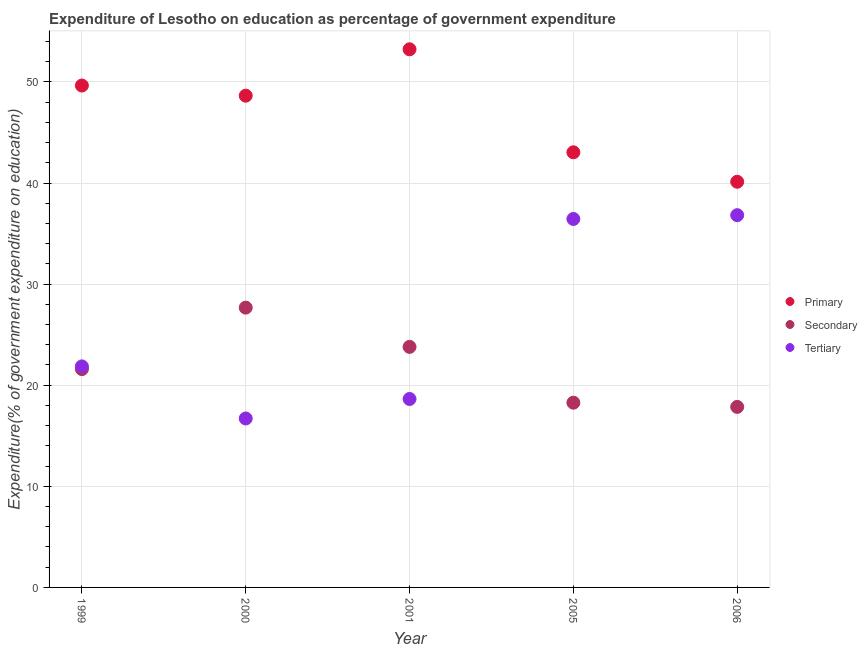How many different coloured dotlines are there?
Ensure brevity in your answer.  3. What is the expenditure on tertiary education in 2001?
Your response must be concise. 18.64. Across all years, what is the maximum expenditure on tertiary education?
Offer a very short reply. 36.82. Across all years, what is the minimum expenditure on secondary education?
Give a very brief answer. 17.86. In which year was the expenditure on primary education maximum?
Provide a short and direct response. 2001. What is the total expenditure on tertiary education in the graph?
Provide a short and direct response. 130.47. What is the difference between the expenditure on tertiary education in 2005 and that in 2006?
Keep it short and to the point. -0.37. What is the difference between the expenditure on tertiary education in 2000 and the expenditure on secondary education in 2005?
Provide a short and direct response. -1.56. What is the average expenditure on tertiary education per year?
Offer a very short reply. 26.09. In the year 2006, what is the difference between the expenditure on primary education and expenditure on secondary education?
Give a very brief answer. 22.27. What is the ratio of the expenditure on tertiary education in 2000 to that in 2001?
Give a very brief answer. 0.9. What is the difference between the highest and the second highest expenditure on secondary education?
Ensure brevity in your answer.  3.88. What is the difference between the highest and the lowest expenditure on tertiary education?
Offer a very short reply. 20.11. Does the expenditure on secondary education monotonically increase over the years?
Provide a succinct answer. No. Is the expenditure on tertiary education strictly less than the expenditure on secondary education over the years?
Your answer should be compact. No. How many years are there in the graph?
Your response must be concise. 5. What is the difference between two consecutive major ticks on the Y-axis?
Your response must be concise. 10. Does the graph contain any zero values?
Provide a short and direct response. No. Where does the legend appear in the graph?
Give a very brief answer. Center right. How are the legend labels stacked?
Give a very brief answer. Vertical. What is the title of the graph?
Provide a succinct answer. Expenditure of Lesotho on education as percentage of government expenditure. What is the label or title of the X-axis?
Offer a very short reply. Year. What is the label or title of the Y-axis?
Provide a short and direct response. Expenditure(% of government expenditure on education). What is the Expenditure(% of government expenditure on education) in Primary in 1999?
Provide a succinct answer. 49.64. What is the Expenditure(% of government expenditure on education) in Secondary in 1999?
Offer a terse response. 21.59. What is the Expenditure(% of government expenditure on education) in Tertiary in 1999?
Make the answer very short. 21.86. What is the Expenditure(% of government expenditure on education) in Primary in 2000?
Offer a terse response. 48.64. What is the Expenditure(% of government expenditure on education) in Secondary in 2000?
Make the answer very short. 27.67. What is the Expenditure(% of government expenditure on education) in Tertiary in 2000?
Provide a short and direct response. 16.71. What is the Expenditure(% of government expenditure on education) in Primary in 2001?
Offer a very short reply. 53.23. What is the Expenditure(% of government expenditure on education) in Secondary in 2001?
Your answer should be very brief. 23.79. What is the Expenditure(% of government expenditure on education) of Tertiary in 2001?
Your response must be concise. 18.64. What is the Expenditure(% of government expenditure on education) in Primary in 2005?
Your response must be concise. 43.04. What is the Expenditure(% of government expenditure on education) of Secondary in 2005?
Offer a very short reply. 18.27. What is the Expenditure(% of government expenditure on education) of Tertiary in 2005?
Make the answer very short. 36.44. What is the Expenditure(% of government expenditure on education) of Primary in 2006?
Provide a succinct answer. 40.12. What is the Expenditure(% of government expenditure on education) of Secondary in 2006?
Ensure brevity in your answer.  17.86. What is the Expenditure(% of government expenditure on education) of Tertiary in 2006?
Offer a terse response. 36.82. Across all years, what is the maximum Expenditure(% of government expenditure on education) of Primary?
Offer a terse response. 53.23. Across all years, what is the maximum Expenditure(% of government expenditure on education) in Secondary?
Keep it short and to the point. 27.67. Across all years, what is the maximum Expenditure(% of government expenditure on education) in Tertiary?
Your answer should be very brief. 36.82. Across all years, what is the minimum Expenditure(% of government expenditure on education) in Primary?
Make the answer very short. 40.12. Across all years, what is the minimum Expenditure(% of government expenditure on education) in Secondary?
Make the answer very short. 17.86. Across all years, what is the minimum Expenditure(% of government expenditure on education) in Tertiary?
Your answer should be compact. 16.71. What is the total Expenditure(% of government expenditure on education) in Primary in the graph?
Keep it short and to the point. 234.67. What is the total Expenditure(% of government expenditure on education) of Secondary in the graph?
Your answer should be compact. 109.19. What is the total Expenditure(% of government expenditure on education) in Tertiary in the graph?
Keep it short and to the point. 130.47. What is the difference between the Expenditure(% of government expenditure on education) of Secondary in 1999 and that in 2000?
Make the answer very short. -6.08. What is the difference between the Expenditure(% of government expenditure on education) in Tertiary in 1999 and that in 2000?
Offer a very short reply. 5.15. What is the difference between the Expenditure(% of government expenditure on education) of Primary in 1999 and that in 2001?
Offer a very short reply. -3.58. What is the difference between the Expenditure(% of government expenditure on education) in Secondary in 1999 and that in 2001?
Keep it short and to the point. -2.2. What is the difference between the Expenditure(% of government expenditure on education) in Tertiary in 1999 and that in 2001?
Your response must be concise. 3.22. What is the difference between the Expenditure(% of government expenditure on education) of Primary in 1999 and that in 2005?
Your response must be concise. 6.61. What is the difference between the Expenditure(% of government expenditure on education) of Secondary in 1999 and that in 2005?
Give a very brief answer. 3.32. What is the difference between the Expenditure(% of government expenditure on education) in Tertiary in 1999 and that in 2005?
Offer a terse response. -14.58. What is the difference between the Expenditure(% of government expenditure on education) of Primary in 1999 and that in 2006?
Provide a succinct answer. 9.52. What is the difference between the Expenditure(% of government expenditure on education) of Secondary in 1999 and that in 2006?
Keep it short and to the point. 3.74. What is the difference between the Expenditure(% of government expenditure on education) in Tertiary in 1999 and that in 2006?
Provide a succinct answer. -14.96. What is the difference between the Expenditure(% of government expenditure on education) in Primary in 2000 and that in 2001?
Provide a short and direct response. -4.59. What is the difference between the Expenditure(% of government expenditure on education) in Secondary in 2000 and that in 2001?
Provide a succinct answer. 3.88. What is the difference between the Expenditure(% of government expenditure on education) in Tertiary in 2000 and that in 2001?
Offer a terse response. -1.93. What is the difference between the Expenditure(% of government expenditure on education) of Primary in 2000 and that in 2005?
Your answer should be compact. 5.6. What is the difference between the Expenditure(% of government expenditure on education) of Secondary in 2000 and that in 2005?
Your answer should be very brief. 9.4. What is the difference between the Expenditure(% of government expenditure on education) in Tertiary in 2000 and that in 2005?
Give a very brief answer. -19.73. What is the difference between the Expenditure(% of government expenditure on education) of Primary in 2000 and that in 2006?
Give a very brief answer. 8.51. What is the difference between the Expenditure(% of government expenditure on education) of Secondary in 2000 and that in 2006?
Provide a succinct answer. 9.82. What is the difference between the Expenditure(% of government expenditure on education) in Tertiary in 2000 and that in 2006?
Ensure brevity in your answer.  -20.11. What is the difference between the Expenditure(% of government expenditure on education) of Primary in 2001 and that in 2005?
Your response must be concise. 10.19. What is the difference between the Expenditure(% of government expenditure on education) in Secondary in 2001 and that in 2005?
Keep it short and to the point. 5.52. What is the difference between the Expenditure(% of government expenditure on education) in Tertiary in 2001 and that in 2005?
Offer a very short reply. -17.81. What is the difference between the Expenditure(% of government expenditure on education) in Primary in 2001 and that in 2006?
Keep it short and to the point. 13.1. What is the difference between the Expenditure(% of government expenditure on education) of Secondary in 2001 and that in 2006?
Ensure brevity in your answer.  5.94. What is the difference between the Expenditure(% of government expenditure on education) in Tertiary in 2001 and that in 2006?
Ensure brevity in your answer.  -18.18. What is the difference between the Expenditure(% of government expenditure on education) of Primary in 2005 and that in 2006?
Provide a short and direct response. 2.91. What is the difference between the Expenditure(% of government expenditure on education) in Secondary in 2005 and that in 2006?
Offer a terse response. 0.42. What is the difference between the Expenditure(% of government expenditure on education) of Tertiary in 2005 and that in 2006?
Provide a succinct answer. -0.37. What is the difference between the Expenditure(% of government expenditure on education) in Primary in 1999 and the Expenditure(% of government expenditure on education) in Secondary in 2000?
Give a very brief answer. 21.97. What is the difference between the Expenditure(% of government expenditure on education) of Primary in 1999 and the Expenditure(% of government expenditure on education) of Tertiary in 2000?
Offer a terse response. 32.93. What is the difference between the Expenditure(% of government expenditure on education) of Secondary in 1999 and the Expenditure(% of government expenditure on education) of Tertiary in 2000?
Your response must be concise. 4.88. What is the difference between the Expenditure(% of government expenditure on education) in Primary in 1999 and the Expenditure(% of government expenditure on education) in Secondary in 2001?
Offer a very short reply. 25.85. What is the difference between the Expenditure(% of government expenditure on education) of Primary in 1999 and the Expenditure(% of government expenditure on education) of Tertiary in 2001?
Provide a short and direct response. 31. What is the difference between the Expenditure(% of government expenditure on education) in Secondary in 1999 and the Expenditure(% of government expenditure on education) in Tertiary in 2001?
Your response must be concise. 2.95. What is the difference between the Expenditure(% of government expenditure on education) of Primary in 1999 and the Expenditure(% of government expenditure on education) of Secondary in 2005?
Your response must be concise. 31.37. What is the difference between the Expenditure(% of government expenditure on education) in Primary in 1999 and the Expenditure(% of government expenditure on education) in Tertiary in 2005?
Provide a succinct answer. 13.2. What is the difference between the Expenditure(% of government expenditure on education) of Secondary in 1999 and the Expenditure(% of government expenditure on education) of Tertiary in 2005?
Your answer should be very brief. -14.85. What is the difference between the Expenditure(% of government expenditure on education) of Primary in 1999 and the Expenditure(% of government expenditure on education) of Secondary in 2006?
Keep it short and to the point. 31.79. What is the difference between the Expenditure(% of government expenditure on education) in Primary in 1999 and the Expenditure(% of government expenditure on education) in Tertiary in 2006?
Provide a succinct answer. 12.82. What is the difference between the Expenditure(% of government expenditure on education) of Secondary in 1999 and the Expenditure(% of government expenditure on education) of Tertiary in 2006?
Your answer should be very brief. -15.23. What is the difference between the Expenditure(% of government expenditure on education) in Primary in 2000 and the Expenditure(% of government expenditure on education) in Secondary in 2001?
Offer a very short reply. 24.85. What is the difference between the Expenditure(% of government expenditure on education) of Primary in 2000 and the Expenditure(% of government expenditure on education) of Tertiary in 2001?
Offer a terse response. 30. What is the difference between the Expenditure(% of government expenditure on education) in Secondary in 2000 and the Expenditure(% of government expenditure on education) in Tertiary in 2001?
Provide a succinct answer. 9.04. What is the difference between the Expenditure(% of government expenditure on education) in Primary in 2000 and the Expenditure(% of government expenditure on education) in Secondary in 2005?
Provide a short and direct response. 30.37. What is the difference between the Expenditure(% of government expenditure on education) of Primary in 2000 and the Expenditure(% of government expenditure on education) of Tertiary in 2005?
Make the answer very short. 12.19. What is the difference between the Expenditure(% of government expenditure on education) in Secondary in 2000 and the Expenditure(% of government expenditure on education) in Tertiary in 2005?
Keep it short and to the point. -8.77. What is the difference between the Expenditure(% of government expenditure on education) of Primary in 2000 and the Expenditure(% of government expenditure on education) of Secondary in 2006?
Provide a short and direct response. 30.78. What is the difference between the Expenditure(% of government expenditure on education) in Primary in 2000 and the Expenditure(% of government expenditure on education) in Tertiary in 2006?
Give a very brief answer. 11.82. What is the difference between the Expenditure(% of government expenditure on education) of Secondary in 2000 and the Expenditure(% of government expenditure on education) of Tertiary in 2006?
Give a very brief answer. -9.14. What is the difference between the Expenditure(% of government expenditure on education) of Primary in 2001 and the Expenditure(% of government expenditure on education) of Secondary in 2005?
Your answer should be very brief. 34.95. What is the difference between the Expenditure(% of government expenditure on education) of Primary in 2001 and the Expenditure(% of government expenditure on education) of Tertiary in 2005?
Make the answer very short. 16.78. What is the difference between the Expenditure(% of government expenditure on education) in Secondary in 2001 and the Expenditure(% of government expenditure on education) in Tertiary in 2005?
Make the answer very short. -12.65. What is the difference between the Expenditure(% of government expenditure on education) of Primary in 2001 and the Expenditure(% of government expenditure on education) of Secondary in 2006?
Provide a short and direct response. 35.37. What is the difference between the Expenditure(% of government expenditure on education) in Primary in 2001 and the Expenditure(% of government expenditure on education) in Tertiary in 2006?
Make the answer very short. 16.41. What is the difference between the Expenditure(% of government expenditure on education) of Secondary in 2001 and the Expenditure(% of government expenditure on education) of Tertiary in 2006?
Your answer should be compact. -13.03. What is the difference between the Expenditure(% of government expenditure on education) in Primary in 2005 and the Expenditure(% of government expenditure on education) in Secondary in 2006?
Offer a terse response. 25.18. What is the difference between the Expenditure(% of government expenditure on education) in Primary in 2005 and the Expenditure(% of government expenditure on education) in Tertiary in 2006?
Make the answer very short. 6.22. What is the difference between the Expenditure(% of government expenditure on education) of Secondary in 2005 and the Expenditure(% of government expenditure on education) of Tertiary in 2006?
Provide a succinct answer. -18.55. What is the average Expenditure(% of government expenditure on education) of Primary per year?
Your answer should be compact. 46.93. What is the average Expenditure(% of government expenditure on education) in Secondary per year?
Offer a very short reply. 21.84. What is the average Expenditure(% of government expenditure on education) in Tertiary per year?
Give a very brief answer. 26.09. In the year 1999, what is the difference between the Expenditure(% of government expenditure on education) of Primary and Expenditure(% of government expenditure on education) of Secondary?
Ensure brevity in your answer.  28.05. In the year 1999, what is the difference between the Expenditure(% of government expenditure on education) in Primary and Expenditure(% of government expenditure on education) in Tertiary?
Provide a short and direct response. 27.78. In the year 1999, what is the difference between the Expenditure(% of government expenditure on education) of Secondary and Expenditure(% of government expenditure on education) of Tertiary?
Provide a succinct answer. -0.27. In the year 2000, what is the difference between the Expenditure(% of government expenditure on education) in Primary and Expenditure(% of government expenditure on education) in Secondary?
Provide a succinct answer. 20.96. In the year 2000, what is the difference between the Expenditure(% of government expenditure on education) in Primary and Expenditure(% of government expenditure on education) in Tertiary?
Give a very brief answer. 31.93. In the year 2000, what is the difference between the Expenditure(% of government expenditure on education) in Secondary and Expenditure(% of government expenditure on education) in Tertiary?
Ensure brevity in your answer.  10.96. In the year 2001, what is the difference between the Expenditure(% of government expenditure on education) of Primary and Expenditure(% of government expenditure on education) of Secondary?
Keep it short and to the point. 29.44. In the year 2001, what is the difference between the Expenditure(% of government expenditure on education) in Primary and Expenditure(% of government expenditure on education) in Tertiary?
Give a very brief answer. 34.59. In the year 2001, what is the difference between the Expenditure(% of government expenditure on education) in Secondary and Expenditure(% of government expenditure on education) in Tertiary?
Keep it short and to the point. 5.15. In the year 2005, what is the difference between the Expenditure(% of government expenditure on education) in Primary and Expenditure(% of government expenditure on education) in Secondary?
Your response must be concise. 24.76. In the year 2005, what is the difference between the Expenditure(% of government expenditure on education) in Primary and Expenditure(% of government expenditure on education) in Tertiary?
Your response must be concise. 6.59. In the year 2005, what is the difference between the Expenditure(% of government expenditure on education) of Secondary and Expenditure(% of government expenditure on education) of Tertiary?
Your answer should be compact. -18.17. In the year 2006, what is the difference between the Expenditure(% of government expenditure on education) of Primary and Expenditure(% of government expenditure on education) of Secondary?
Give a very brief answer. 22.27. In the year 2006, what is the difference between the Expenditure(% of government expenditure on education) of Primary and Expenditure(% of government expenditure on education) of Tertiary?
Provide a succinct answer. 3.31. In the year 2006, what is the difference between the Expenditure(% of government expenditure on education) in Secondary and Expenditure(% of government expenditure on education) in Tertiary?
Provide a short and direct response. -18.96. What is the ratio of the Expenditure(% of government expenditure on education) in Primary in 1999 to that in 2000?
Make the answer very short. 1.02. What is the ratio of the Expenditure(% of government expenditure on education) in Secondary in 1999 to that in 2000?
Give a very brief answer. 0.78. What is the ratio of the Expenditure(% of government expenditure on education) of Tertiary in 1999 to that in 2000?
Your answer should be compact. 1.31. What is the ratio of the Expenditure(% of government expenditure on education) in Primary in 1999 to that in 2001?
Offer a terse response. 0.93. What is the ratio of the Expenditure(% of government expenditure on education) of Secondary in 1999 to that in 2001?
Offer a very short reply. 0.91. What is the ratio of the Expenditure(% of government expenditure on education) in Tertiary in 1999 to that in 2001?
Ensure brevity in your answer.  1.17. What is the ratio of the Expenditure(% of government expenditure on education) in Primary in 1999 to that in 2005?
Offer a terse response. 1.15. What is the ratio of the Expenditure(% of government expenditure on education) in Secondary in 1999 to that in 2005?
Keep it short and to the point. 1.18. What is the ratio of the Expenditure(% of government expenditure on education) in Tertiary in 1999 to that in 2005?
Your response must be concise. 0.6. What is the ratio of the Expenditure(% of government expenditure on education) of Primary in 1999 to that in 2006?
Ensure brevity in your answer.  1.24. What is the ratio of the Expenditure(% of government expenditure on education) in Secondary in 1999 to that in 2006?
Keep it short and to the point. 1.21. What is the ratio of the Expenditure(% of government expenditure on education) in Tertiary in 1999 to that in 2006?
Provide a short and direct response. 0.59. What is the ratio of the Expenditure(% of government expenditure on education) in Primary in 2000 to that in 2001?
Your answer should be very brief. 0.91. What is the ratio of the Expenditure(% of government expenditure on education) in Secondary in 2000 to that in 2001?
Make the answer very short. 1.16. What is the ratio of the Expenditure(% of government expenditure on education) of Tertiary in 2000 to that in 2001?
Ensure brevity in your answer.  0.9. What is the ratio of the Expenditure(% of government expenditure on education) of Primary in 2000 to that in 2005?
Offer a terse response. 1.13. What is the ratio of the Expenditure(% of government expenditure on education) in Secondary in 2000 to that in 2005?
Offer a terse response. 1.51. What is the ratio of the Expenditure(% of government expenditure on education) in Tertiary in 2000 to that in 2005?
Your answer should be very brief. 0.46. What is the ratio of the Expenditure(% of government expenditure on education) of Primary in 2000 to that in 2006?
Provide a succinct answer. 1.21. What is the ratio of the Expenditure(% of government expenditure on education) of Secondary in 2000 to that in 2006?
Ensure brevity in your answer.  1.55. What is the ratio of the Expenditure(% of government expenditure on education) of Tertiary in 2000 to that in 2006?
Offer a terse response. 0.45. What is the ratio of the Expenditure(% of government expenditure on education) in Primary in 2001 to that in 2005?
Your answer should be compact. 1.24. What is the ratio of the Expenditure(% of government expenditure on education) in Secondary in 2001 to that in 2005?
Offer a terse response. 1.3. What is the ratio of the Expenditure(% of government expenditure on education) in Tertiary in 2001 to that in 2005?
Your response must be concise. 0.51. What is the ratio of the Expenditure(% of government expenditure on education) of Primary in 2001 to that in 2006?
Your response must be concise. 1.33. What is the ratio of the Expenditure(% of government expenditure on education) in Secondary in 2001 to that in 2006?
Offer a terse response. 1.33. What is the ratio of the Expenditure(% of government expenditure on education) in Tertiary in 2001 to that in 2006?
Offer a terse response. 0.51. What is the ratio of the Expenditure(% of government expenditure on education) of Primary in 2005 to that in 2006?
Keep it short and to the point. 1.07. What is the ratio of the Expenditure(% of government expenditure on education) of Secondary in 2005 to that in 2006?
Offer a very short reply. 1.02. What is the difference between the highest and the second highest Expenditure(% of government expenditure on education) in Primary?
Ensure brevity in your answer.  3.58. What is the difference between the highest and the second highest Expenditure(% of government expenditure on education) of Secondary?
Your answer should be very brief. 3.88. What is the difference between the highest and the second highest Expenditure(% of government expenditure on education) of Tertiary?
Your answer should be very brief. 0.37. What is the difference between the highest and the lowest Expenditure(% of government expenditure on education) of Primary?
Give a very brief answer. 13.1. What is the difference between the highest and the lowest Expenditure(% of government expenditure on education) of Secondary?
Offer a very short reply. 9.82. What is the difference between the highest and the lowest Expenditure(% of government expenditure on education) of Tertiary?
Your answer should be very brief. 20.11. 